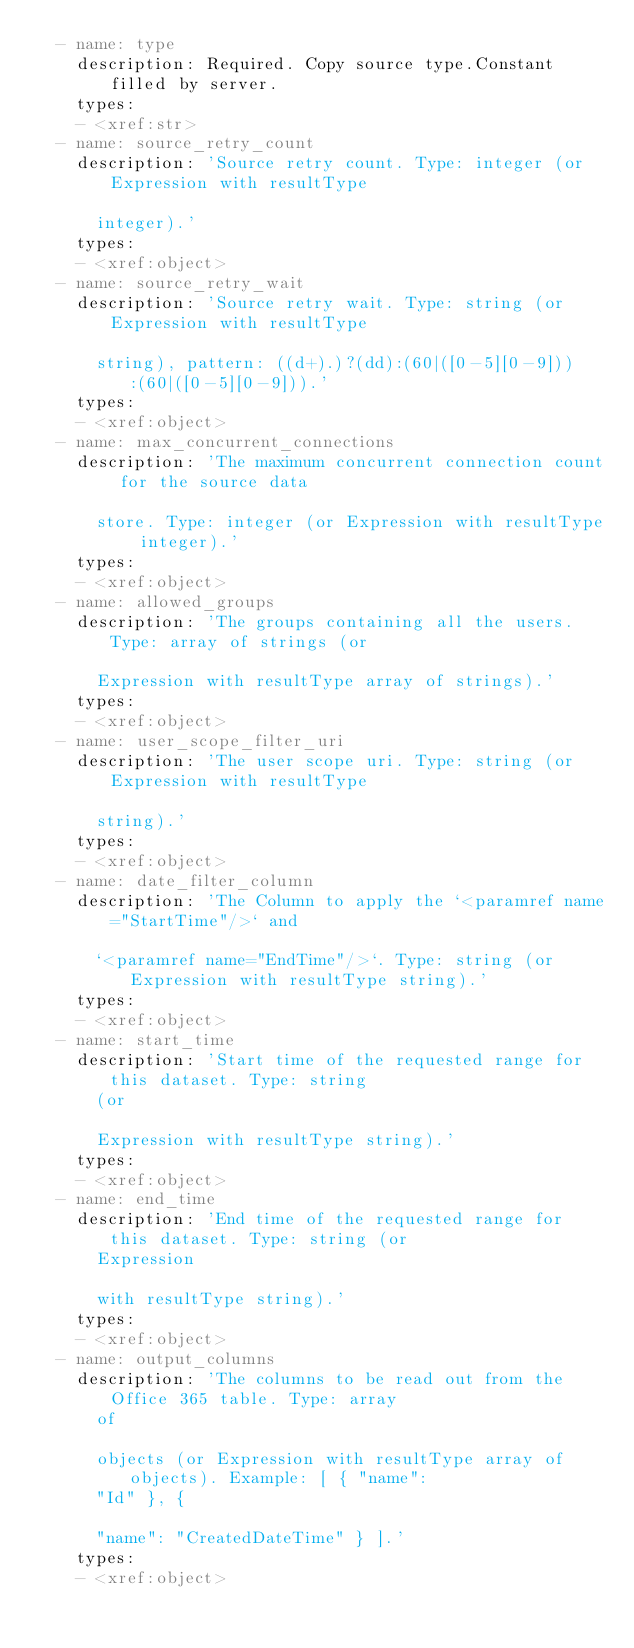Convert code to text. <code><loc_0><loc_0><loc_500><loc_500><_YAML_>  - name: type
    description: Required. Copy source type.Constant filled by server.
    types:
    - <xref:str>
  - name: source_retry_count
    description: 'Source retry count. Type: integer (or Expression with resultType

      integer).'
    types:
    - <xref:object>
  - name: source_retry_wait
    description: 'Source retry wait. Type: string (or Expression with resultType

      string), pattern: ((d+).)?(dd):(60|([0-5][0-9])):(60|([0-5][0-9])).'
    types:
    - <xref:object>
  - name: max_concurrent_connections
    description: 'The maximum concurrent connection count for the source data

      store. Type: integer (or Expression with resultType integer).'
    types:
    - <xref:object>
  - name: allowed_groups
    description: 'The groups containing all the users. Type: array of strings (or

      Expression with resultType array of strings).'
    types:
    - <xref:object>
  - name: user_scope_filter_uri
    description: 'The user scope uri. Type: string (or Expression with resultType

      string).'
    types:
    - <xref:object>
  - name: date_filter_column
    description: 'The Column to apply the `<paramref name="StartTime"/>` and

      `<paramref name="EndTime"/>`. Type: string (or Expression with resultType string).'
    types:
    - <xref:object>
  - name: start_time
    description: 'Start time of the requested range for this dataset. Type: string
      (or

      Expression with resultType string).'
    types:
    - <xref:object>
  - name: end_time
    description: 'End time of the requested range for this dataset. Type: string (or
      Expression

      with resultType string).'
    types:
    - <xref:object>
  - name: output_columns
    description: 'The columns to be read out from the Office 365 table. Type: array
      of

      objects (or Expression with resultType array of objects). Example: [ { "name":
      "Id" }, {

      "name": "CreatedDateTime" } ].'
    types:
    - <xref:object>
</code> 